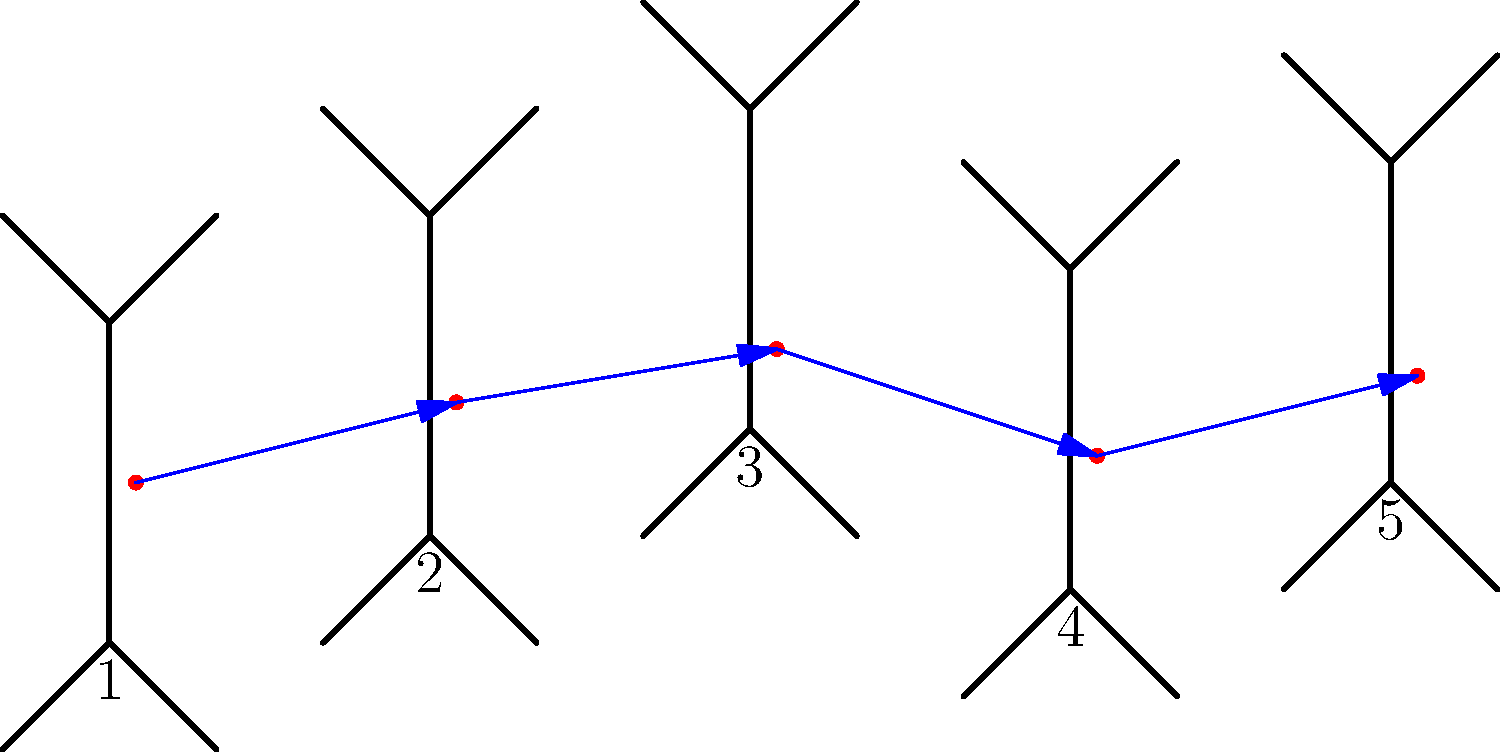Analyze the center of mass shift during the complex floor routine represented by the stick figure sequence. If the height of each stick figure is 1.5 meters, what is the approximate total vertical displacement of the center of mass from position 1 to position 5? Express your answer in centimeters. To solve this problem, we need to follow these steps:

1. Understand the scale: Each stick figure represents 1.5 meters in height.

2. Identify the center of mass (COM) positions:
   The red dots represent the COM for each position.

3. Focus on the vertical displacement:
   We need to calculate the difference in height between the COM in position 1 and position 5.

4. Estimate the relative heights:
   - Position 1 COM: approximately 1/2 of the figure's height
   - Position 5 COM: approximately 5/8 of the figure's height

5. Calculate the vertical displacement:
   - Height difference = (5/8 - 1/2) = 1/8 of the figure's height
   - Figure height = 1.5 meters = 150 cm
   - Vertical displacement = 1/8 * 150 cm = 18.75 cm

6. Round to a reasonable precision:
   Given the nature of the estimation, rounding to 20 cm is appropriate.
Answer: 20 cm 